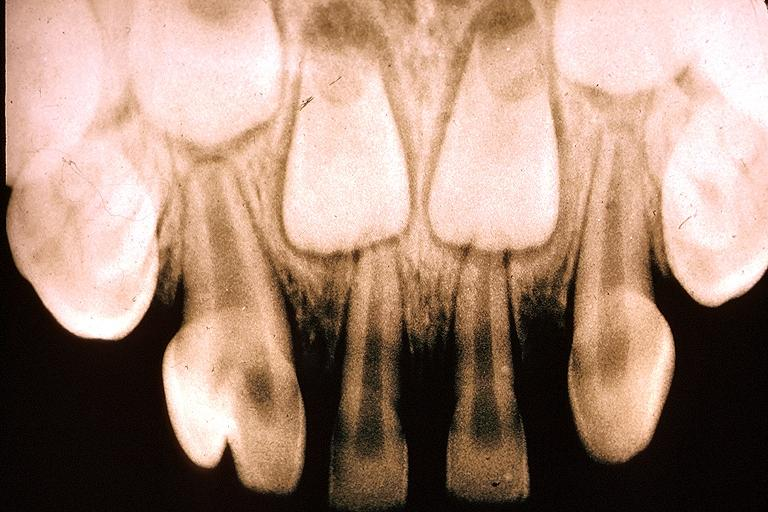s meningitis acute present?
Answer the question using a single word or phrase. No 